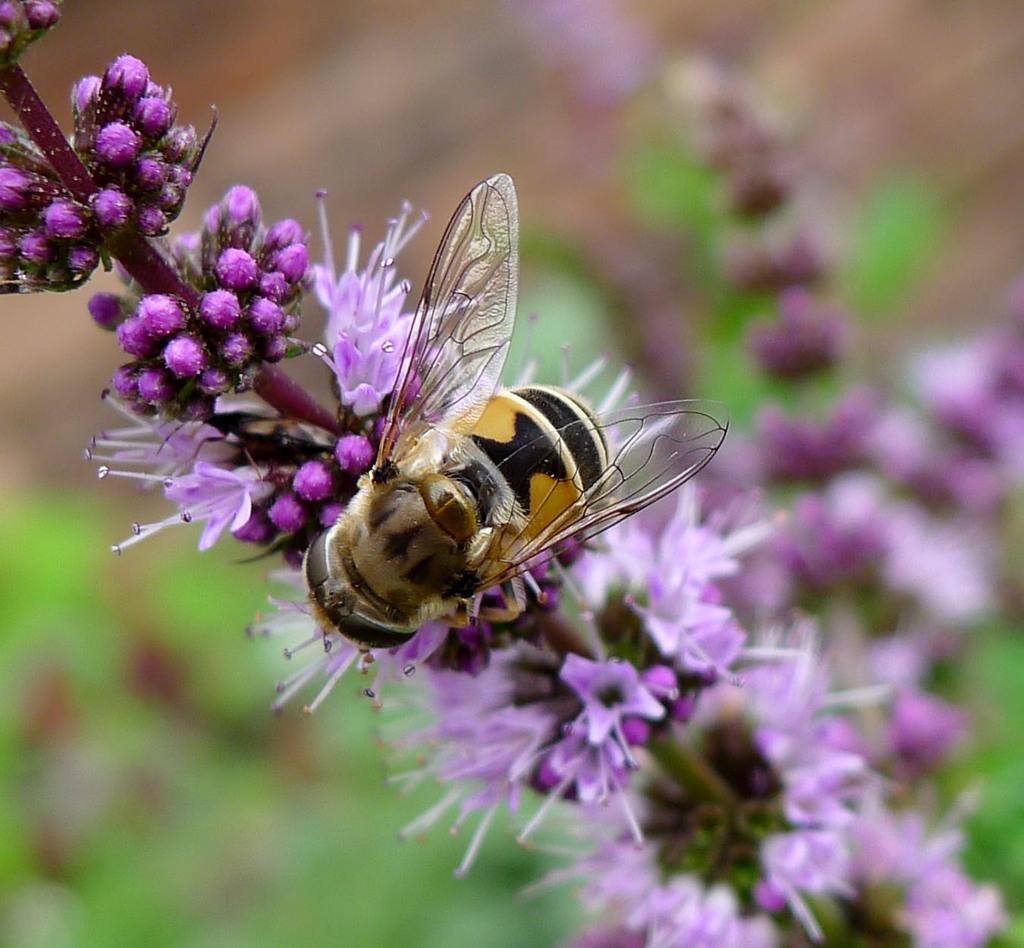Describe this image in one or two sentences. In the picture I can see a honey bee on the branch of a flowering plant. 